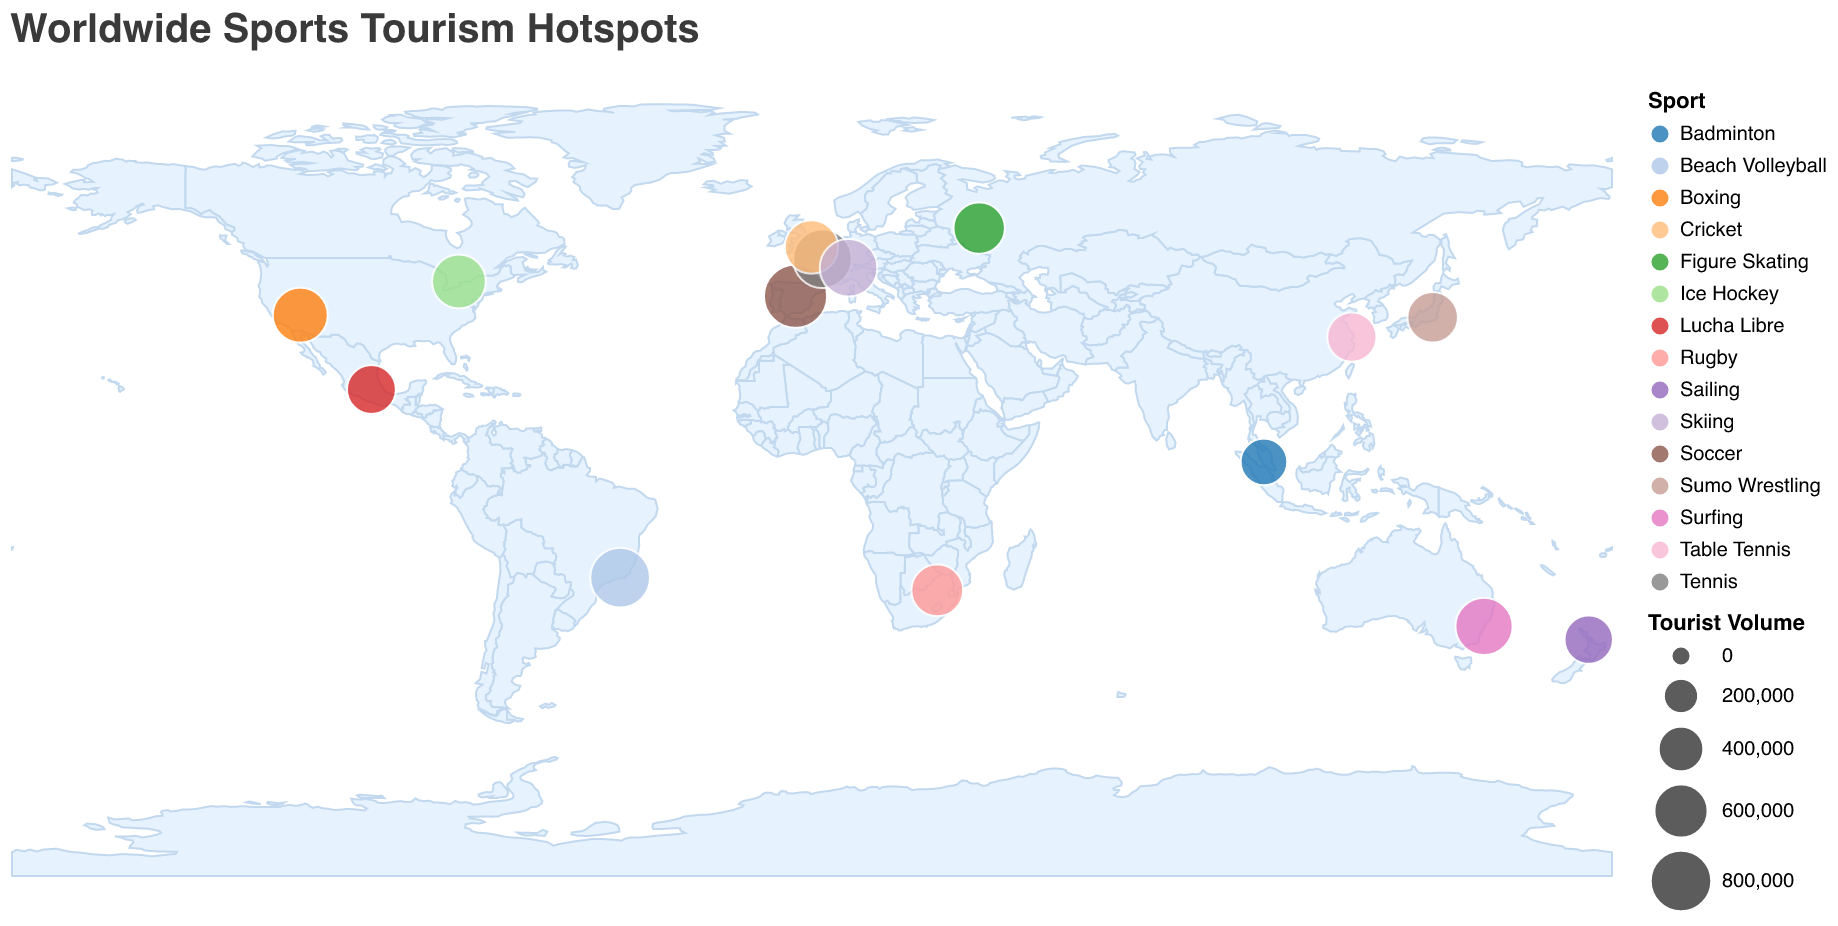Which location has the highest tourist volume for sports tourism? The data plot shows circles of different sizes representing the tourist volume. By identifying the largest circle, we find that Madrid, Spain has the largest circle with a tourist volume of 850,000 for Soccer.
Answer: Madrid, Spain Which sport attracts the most tourists in Brazil? By checking the tooltip or legend near Rio de Janeiro, Brazil, we see that the sport is Beach Volleyball with a tourist volume of 750,000.
Answer: Beach Volleyball What is the total tourist volume for sports in cities located in Europe? Sum the tourist volumes for Madrid (850,000), Paris (720,000), London (580,000), and Interlaken (690,000) to get 850,000 + 720,000 + 580,000 + 690,000 = 2,840,000.
Answer: 2,840,000 Which city is represented by a circle with the approximate geographic coordinates 35.6762, 139.6503 on the map? By checking the provided data points, these coordinates correspond to Tokyo, Japan, which is associated with Sumo Wrestling and a tourist volume of 510,000.
Answer: Tokyo, Japan Which sport has the lowest tourist volume and in which city? By identifying the smallest circle on the plot and checking the tooltip or legend, we find that Badminton in Kuala Lumpur, Malaysia, has the lowest tourist volume of 420,000.
Answer: Badminton in Kuala Lumpur, Malaysia How does the tourist volume for Boxing in Las Vegas compare to Rugby in Pretoria? The tourist volume for Boxing in Las Vegas is 620,000, while Rugby in Pretoria has 540,000. Comparing these values, Boxing in Las Vegas has a higher tourist volume by 620,000 - 540,000 = 80,000.
Answer: Boxing in Las Vegas is higher by 80,000 Are there any sports with similar tourist volumes, and can you name them? By closely looking at the sizes of the circles and the data values, Skiing in Interlaken (690,000) and Surfing in Sydney (680,000) have similar tourist volumes.
Answer: Skiing in Interlaken and Surfing in Sydney Between Ice Hockey in Toronto and Figure Skating in Moscow, which sport destination draws more tourists? By comparing the tourist volumes from the provided data, Ice Hockey in Toronto has a tourist volume of 590,000, while Figure Skating in Moscow has 530,000. Thus, Ice Hockey in Toronto draws more tourists.
Answer: Ice Hockey in Toronto What's the average tourist volume for the sports in North America (Toronto and Las Vegas)? The tourist volumes for Toronto (590,000) and Las Vegas (620,000) sum up to 590,000 + 620,000 = 1,210,000. The average is 1,210,000 / 2 = 605,000.
Answer: 605,000 